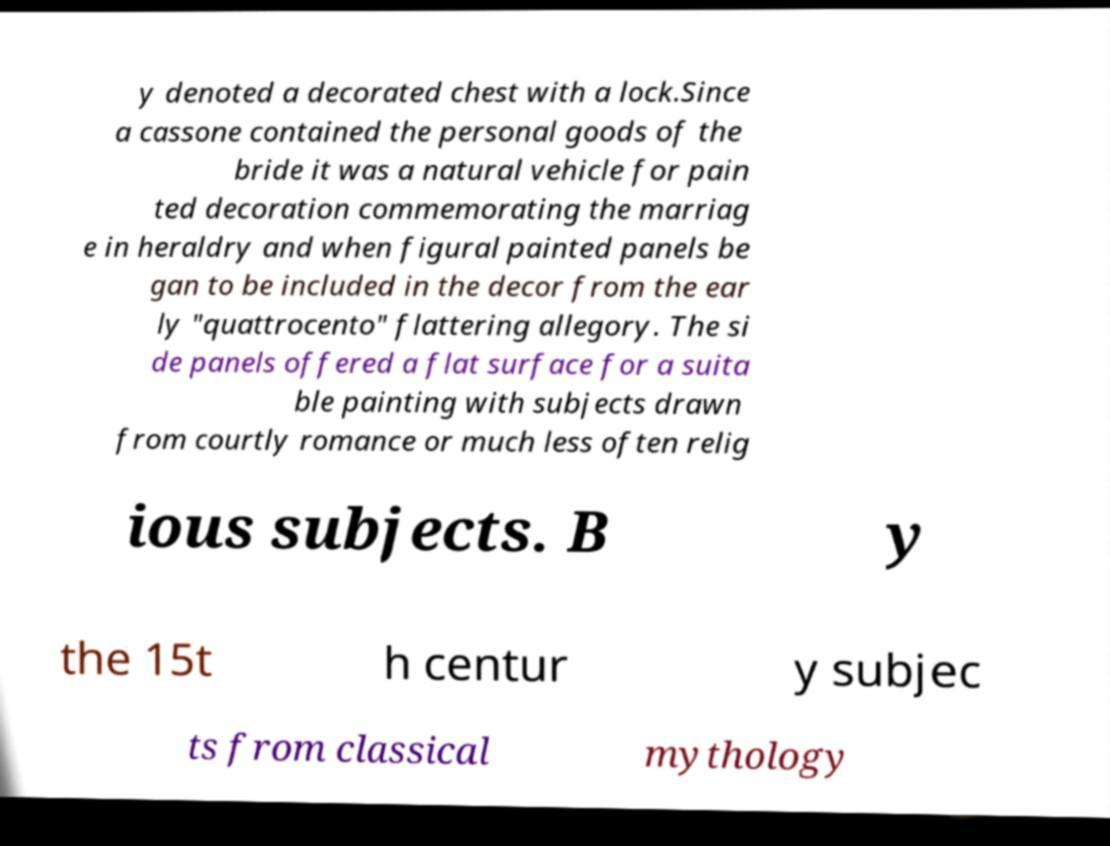Can you read and provide the text displayed in the image?This photo seems to have some interesting text. Can you extract and type it out for me? y denoted a decorated chest with a lock.Since a cassone contained the personal goods of the bride it was a natural vehicle for pain ted decoration commemorating the marriag e in heraldry and when figural painted panels be gan to be included in the decor from the ear ly "quattrocento" flattering allegory. The si de panels offered a flat surface for a suita ble painting with subjects drawn from courtly romance or much less often relig ious subjects. B y the 15t h centur y subjec ts from classical mythology 